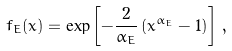<formula> <loc_0><loc_0><loc_500><loc_500>f _ { E } ( x ) = \exp \left [ - \frac { 2 } { \alpha _ { E } } \left ( x ^ { \alpha _ { E } } - 1 \right ) \right ] \, ,</formula> 